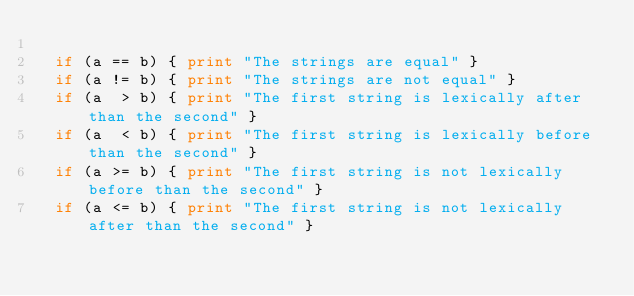<code> <loc_0><loc_0><loc_500><loc_500><_Awk_>
  if (a == b) { print "The strings are equal" }
  if (a != b) { print "The strings are not equal" }
  if (a  > b) { print "The first string is lexically after than the second" }
  if (a  < b) { print "The first string is lexically before than the second" }
  if (a >= b) { print "The first string is not lexically before than the second" }
  if (a <= b) { print "The first string is not lexically after than the second" }
</code> 